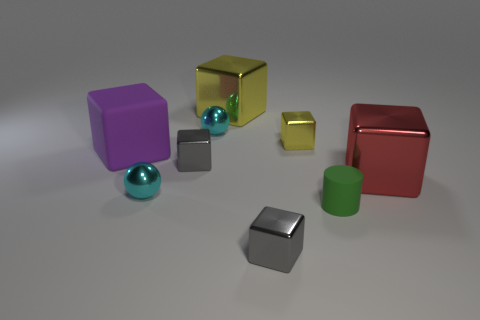Subtract all red blocks. How many blocks are left? 5 Subtract all big yellow blocks. How many blocks are left? 5 Subtract all blue cubes. Subtract all red cylinders. How many cubes are left? 6 Add 1 big cubes. How many objects exist? 10 Subtract all spheres. How many objects are left? 7 Add 1 spheres. How many spheres are left? 3 Add 3 big things. How many big things exist? 6 Subtract 0 purple spheres. How many objects are left? 9 Subtract all green cylinders. Subtract all large yellow shiny things. How many objects are left? 7 